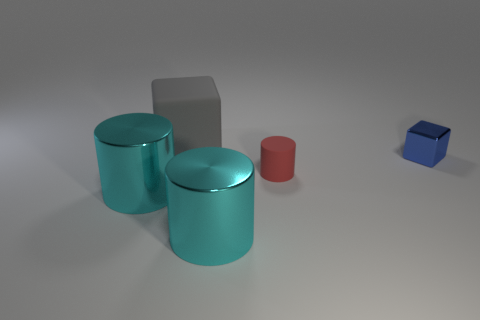Add 1 big red matte cubes. How many objects exist? 6 Subtract all cubes. How many objects are left? 3 Subtract all small yellow rubber cubes. Subtract all small blue metal blocks. How many objects are left? 4 Add 1 objects. How many objects are left? 6 Add 3 small red metal things. How many small red metal things exist? 3 Subtract 1 blue cubes. How many objects are left? 4 